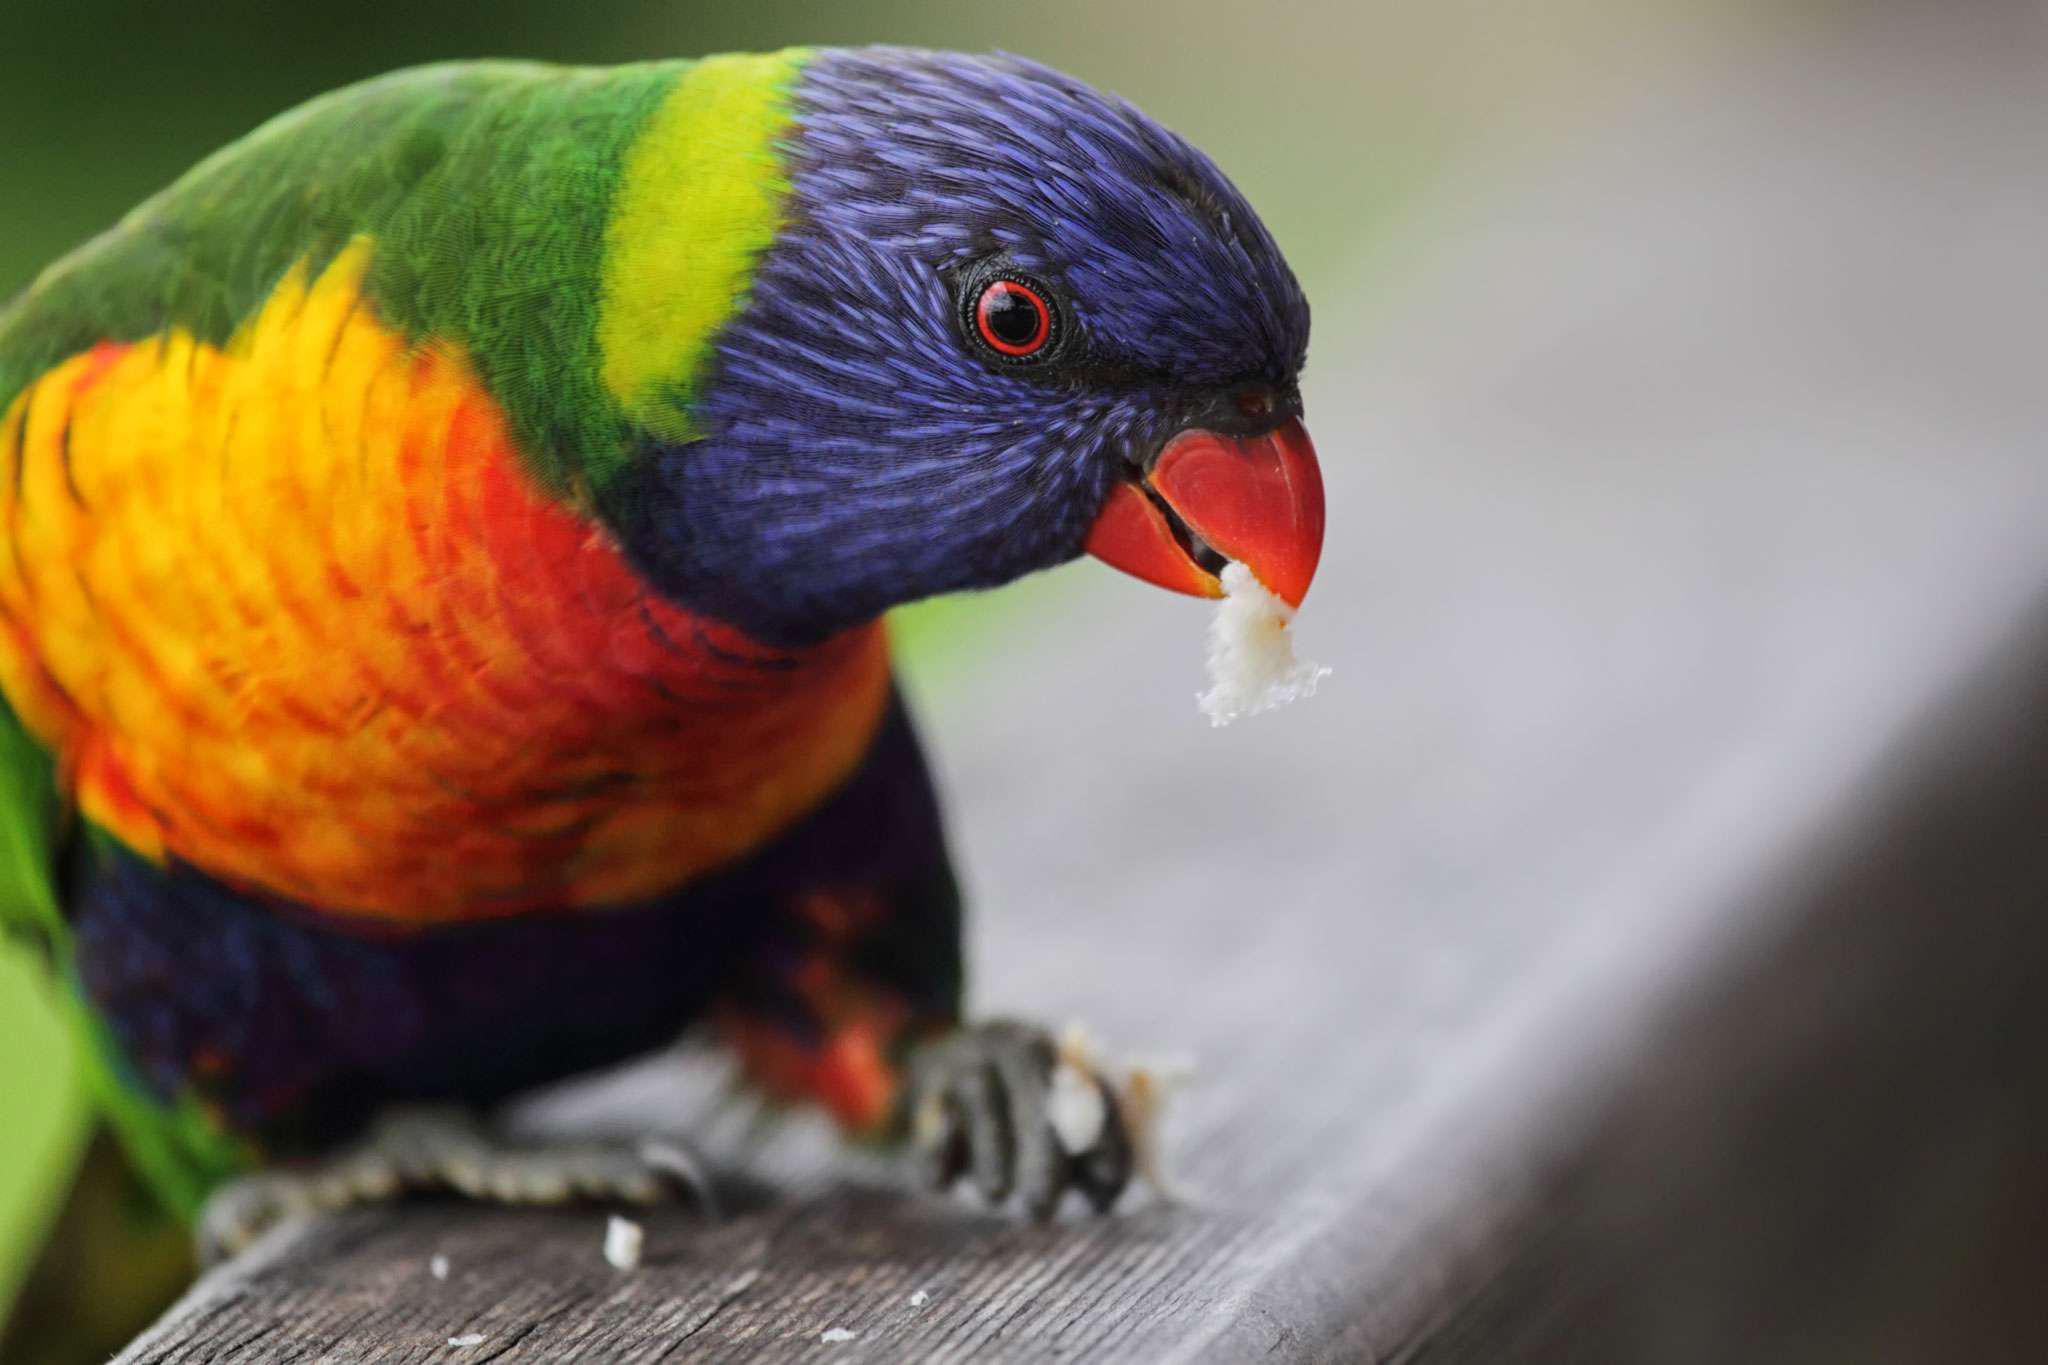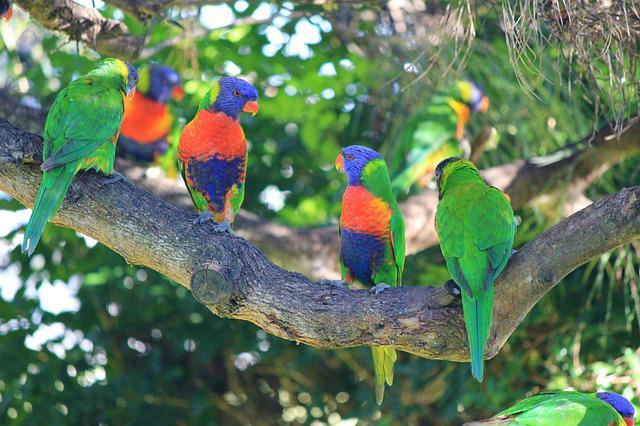The first image is the image on the left, the second image is the image on the right. Considering the images on both sides, is "There are exactly three birds in the image on the right." valid? Answer yes or no. No. 